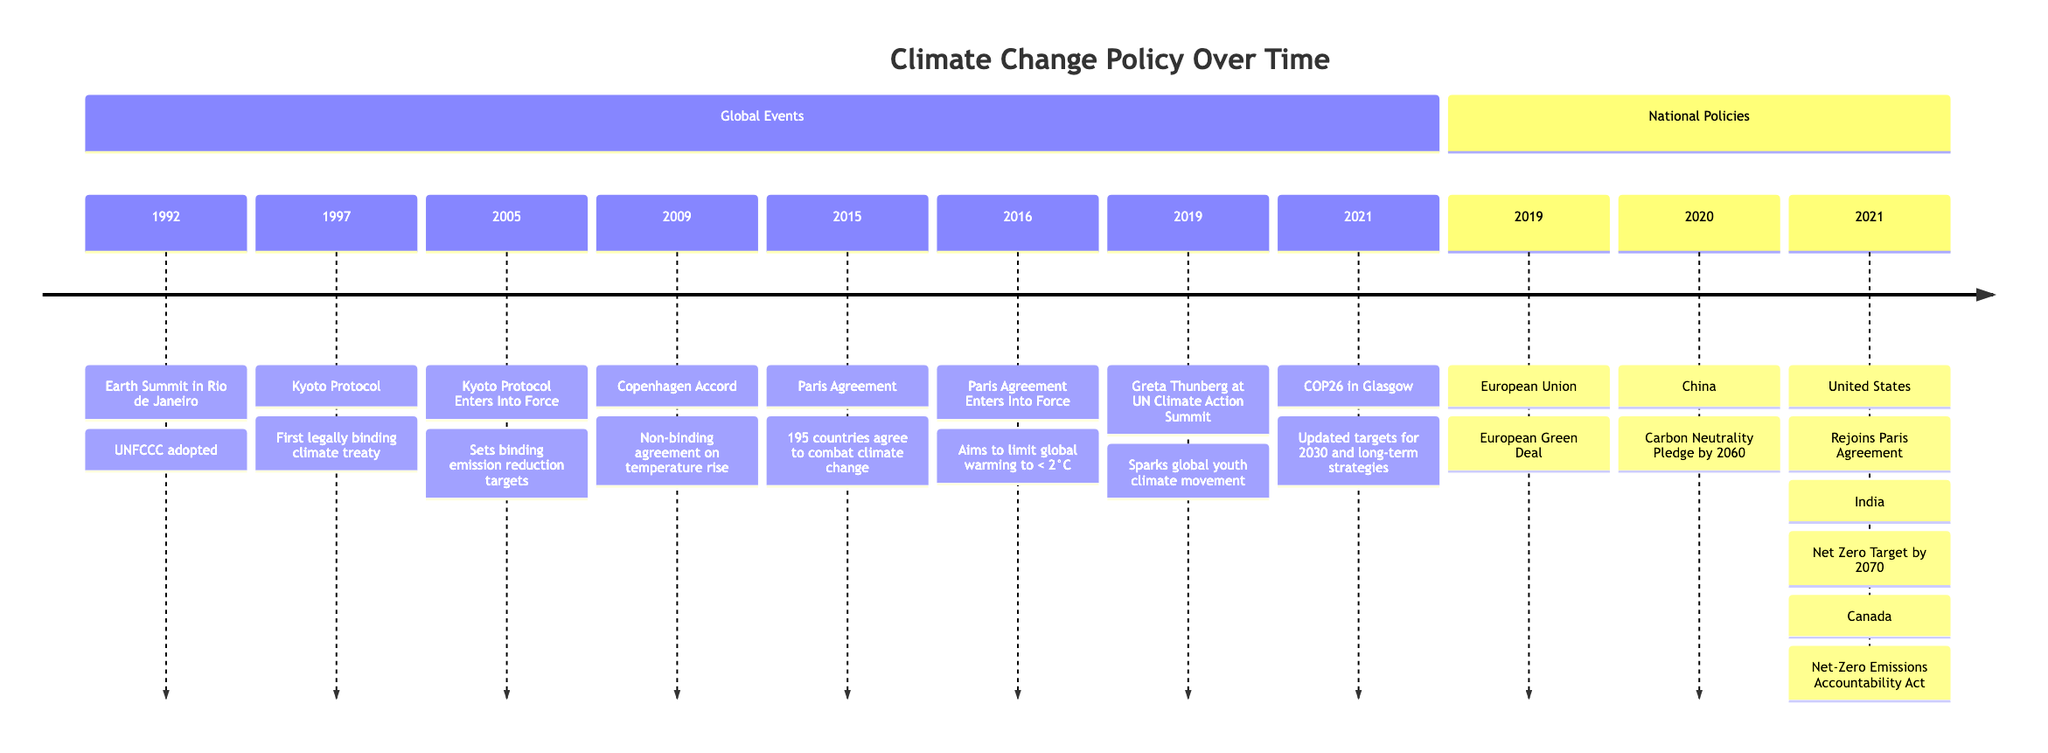What year was the Kyoto Protocol adopted? The diagram lists the Kyoto Protocol under the "Global Events" section, indicating it was adopted in 1997.
Answer: 1997 Which key event sparked the global youth climate movement? The diagram shows that Greta Thunberg at the UN Climate Action Summit in 2019 is highlighted, indicating this event sparked the movement.
Answer: Greta Thunberg How many countries agreed to the Paris Agreement? The diagram states that 195 countries agreed to the Paris Agreement in 2015, indicating this specific number in the timeline.
Answer: 195 What was the first legally binding climate treaty? The diagram explicitly identifies the Kyoto Protocol as the first legally binding climate treaty in 1997.
Answer: Kyoto Protocol In which year did the United States rejoin the Paris Agreement? The diagram shows that the United States rejoined the Paris Agreement in 2021.
Answer: 2021 What notable pledge did China make in 2020 regarding climate change? The timeline indicates that in 2020, China made a Carbon Neutrality Pledge by 2060, which is a significant commitment to climate action.
Answer: Carbon Neutrality Pledge by 2060 Which event marked the entry into force of the Paris Agreement? According to the timeline, the Paris Agreement entered into force in 2016, marking a significant milestone in climate policy.
Answer: 2016 Which country proposed the Net Zero Target by 2070? The diagram indicates that India proposed the Net Zero Target by 2070 in 2021.
Answer: India What major policy was announced by the European Union in 2019? The diagram indicates that the European Union announced the European Green Deal as a major climate policy in 2019.
Answer: European Green Deal 